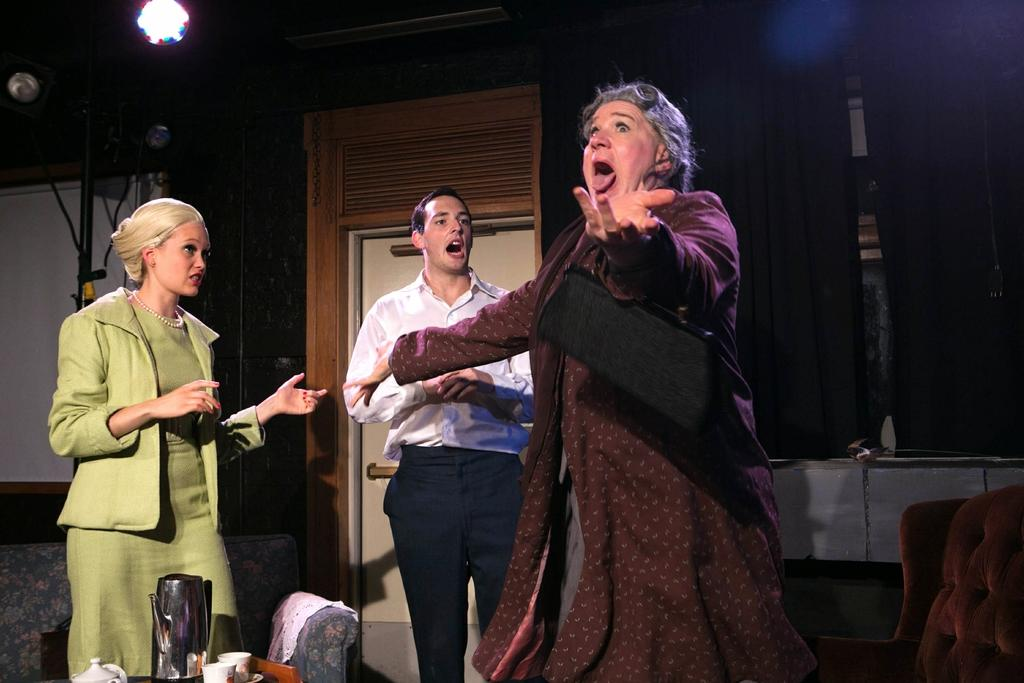How many people are present in the image? There are three people in the image. What objects can be seen in the image related to serving or preparing hot beverages? There are kettles and cups in the image. What type of furniture is present in the image? There are chairs in the image. Can you describe the background of the image? There is a wall, curtains, a white banner, a door, lights, a rod, and cables in the background of the image. What type of history is being taught in the image? There is no indication of any history being taught or discussed in the image. What type of produce is being sold in the image? There is no produce visible in the image. How does the image demonstrate the acoustics of the room? The image does not demonstrate the acoustics of the room; it simply shows people, objects, and a background setting. 